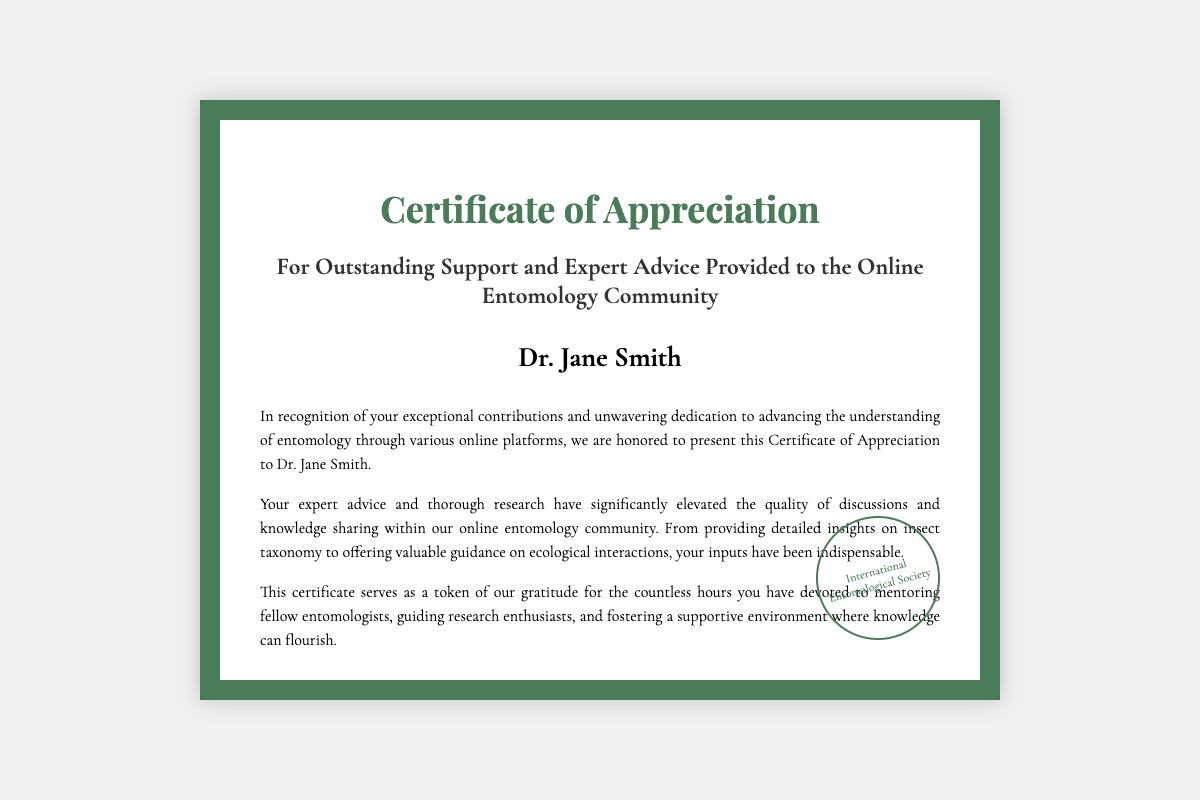What is the title of the certificate? The title of the certificate is clearly stated in the document, which recognizes contributions to the online entomology community.
Answer: Certificate of Appreciation Who is the recipient of the certificate? The recipient's name is prominently featured in the document, indicating who is being honored.
Answer: Dr. Jane Smith What date was the certificate issued? The specific date of issuance is mentioned in the document.
Answer: October 10, 2023 Who is the issuer of the certificate? The organization issuing the certificate is referenced in the document, identifying the governing body.
Answer: International Entomological Society What is the location of the issuer? The document specifies the location associated with the issuer, providing geographical context.
Answer: Washington, D.C., USA What is noted as the main contribution of Dr. Jane Smith? The document elaborates on what Dr. Jane Smith has contributed to the community, highlighting her role.
Answer: Expert advice and thorough research Who signed the certificate? The signature on the certificate identifies the individual authorizing it, providing personal acknowledgment.
Answer: Dr. Emily Turner What is mentioned as a key quality of discussions in the community? The document speaks to the impact of the recipient's contributions on the quality of interactions within the community.
Answer: Elevated the quality of discussions 